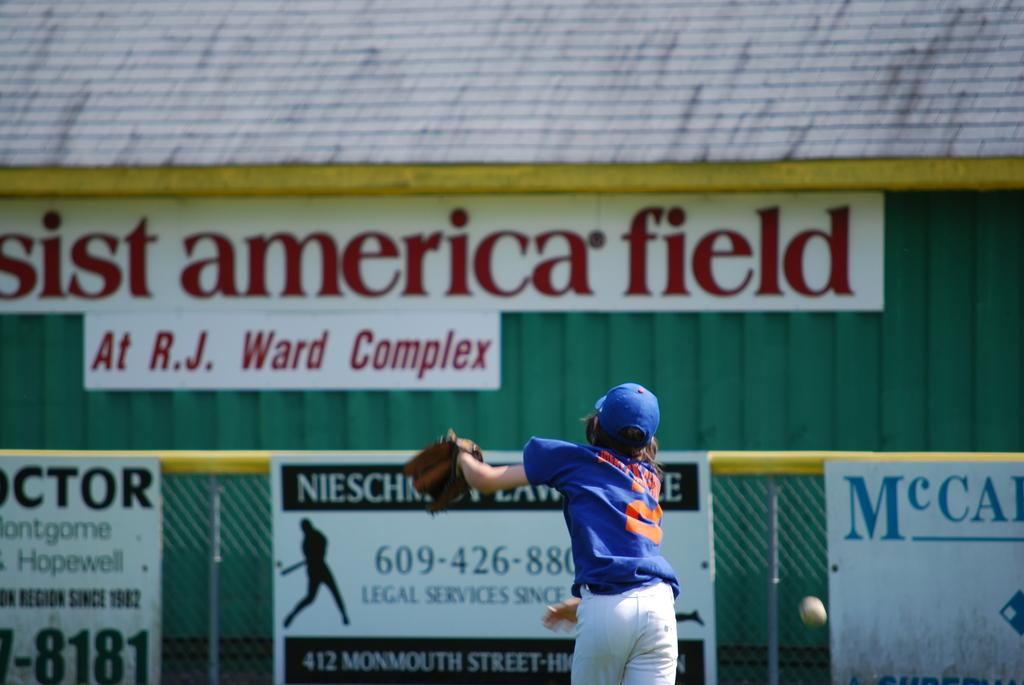<image>
Present a compact description of the photo's key features. A baseball game is being played on a field at R.J. Ward Complex. 